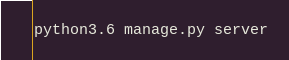Convert code to text. <code><loc_0><loc_0><loc_500><loc_500><_Bash_>
python3.6 manage.py server</code> 